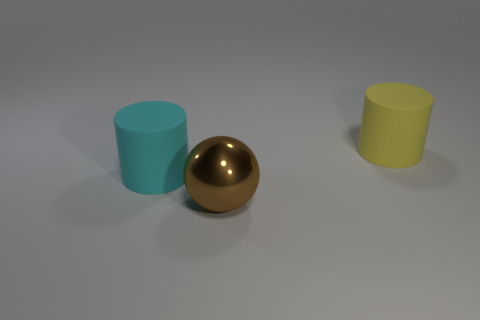Add 3 yellow cylinders. How many objects exist? 6 Subtract all cyan cylinders. How many cylinders are left? 1 Subtract 0 gray blocks. How many objects are left? 3 Subtract all spheres. How many objects are left? 2 Subtract all purple balls. Subtract all blue cylinders. How many balls are left? 1 Subtract all green cubes. How many gray cylinders are left? 0 Subtract all yellow rubber objects. Subtract all large gray metallic balls. How many objects are left? 2 Add 1 large cyan matte cylinders. How many large cyan matte cylinders are left? 2 Add 2 red metallic spheres. How many red metallic spheres exist? 2 